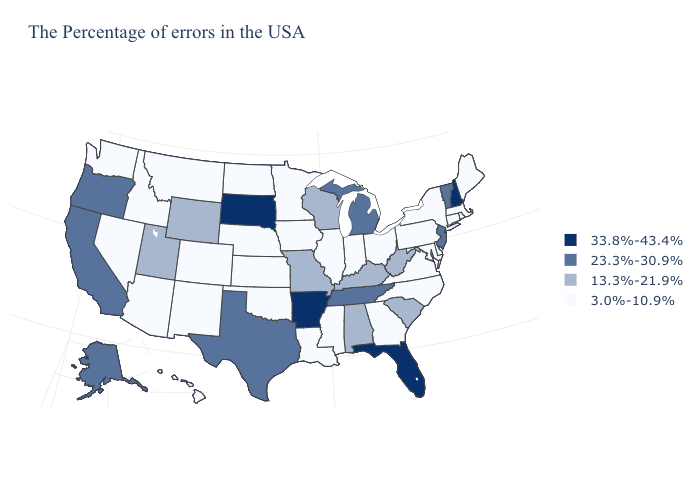What is the value of Minnesota?
Be succinct. 3.0%-10.9%. Is the legend a continuous bar?
Be succinct. No. What is the highest value in states that border Massachusetts?
Write a very short answer. 33.8%-43.4%. Name the states that have a value in the range 33.8%-43.4%?
Short answer required. New Hampshire, Florida, Arkansas, South Dakota. Name the states that have a value in the range 3.0%-10.9%?
Write a very short answer. Maine, Massachusetts, Rhode Island, Connecticut, New York, Delaware, Maryland, Pennsylvania, Virginia, North Carolina, Ohio, Georgia, Indiana, Illinois, Mississippi, Louisiana, Minnesota, Iowa, Kansas, Nebraska, Oklahoma, North Dakota, Colorado, New Mexico, Montana, Arizona, Idaho, Nevada, Washington, Hawaii. Name the states that have a value in the range 3.0%-10.9%?
Short answer required. Maine, Massachusetts, Rhode Island, Connecticut, New York, Delaware, Maryland, Pennsylvania, Virginia, North Carolina, Ohio, Georgia, Indiana, Illinois, Mississippi, Louisiana, Minnesota, Iowa, Kansas, Nebraska, Oklahoma, North Dakota, Colorado, New Mexico, Montana, Arizona, Idaho, Nevada, Washington, Hawaii. What is the value of Connecticut?
Keep it brief. 3.0%-10.9%. Does Delaware have the lowest value in the USA?
Short answer required. Yes. Does Montana have the highest value in the West?
Write a very short answer. No. Among the states that border Colorado , does Arizona have the lowest value?
Quick response, please. Yes. Among the states that border New Hampshire , which have the lowest value?
Concise answer only. Maine, Massachusetts. Which states hav the highest value in the MidWest?
Be succinct. South Dakota. Does the first symbol in the legend represent the smallest category?
Concise answer only. No. What is the highest value in the USA?
Give a very brief answer. 33.8%-43.4%. Which states have the highest value in the USA?
Give a very brief answer. New Hampshire, Florida, Arkansas, South Dakota. 